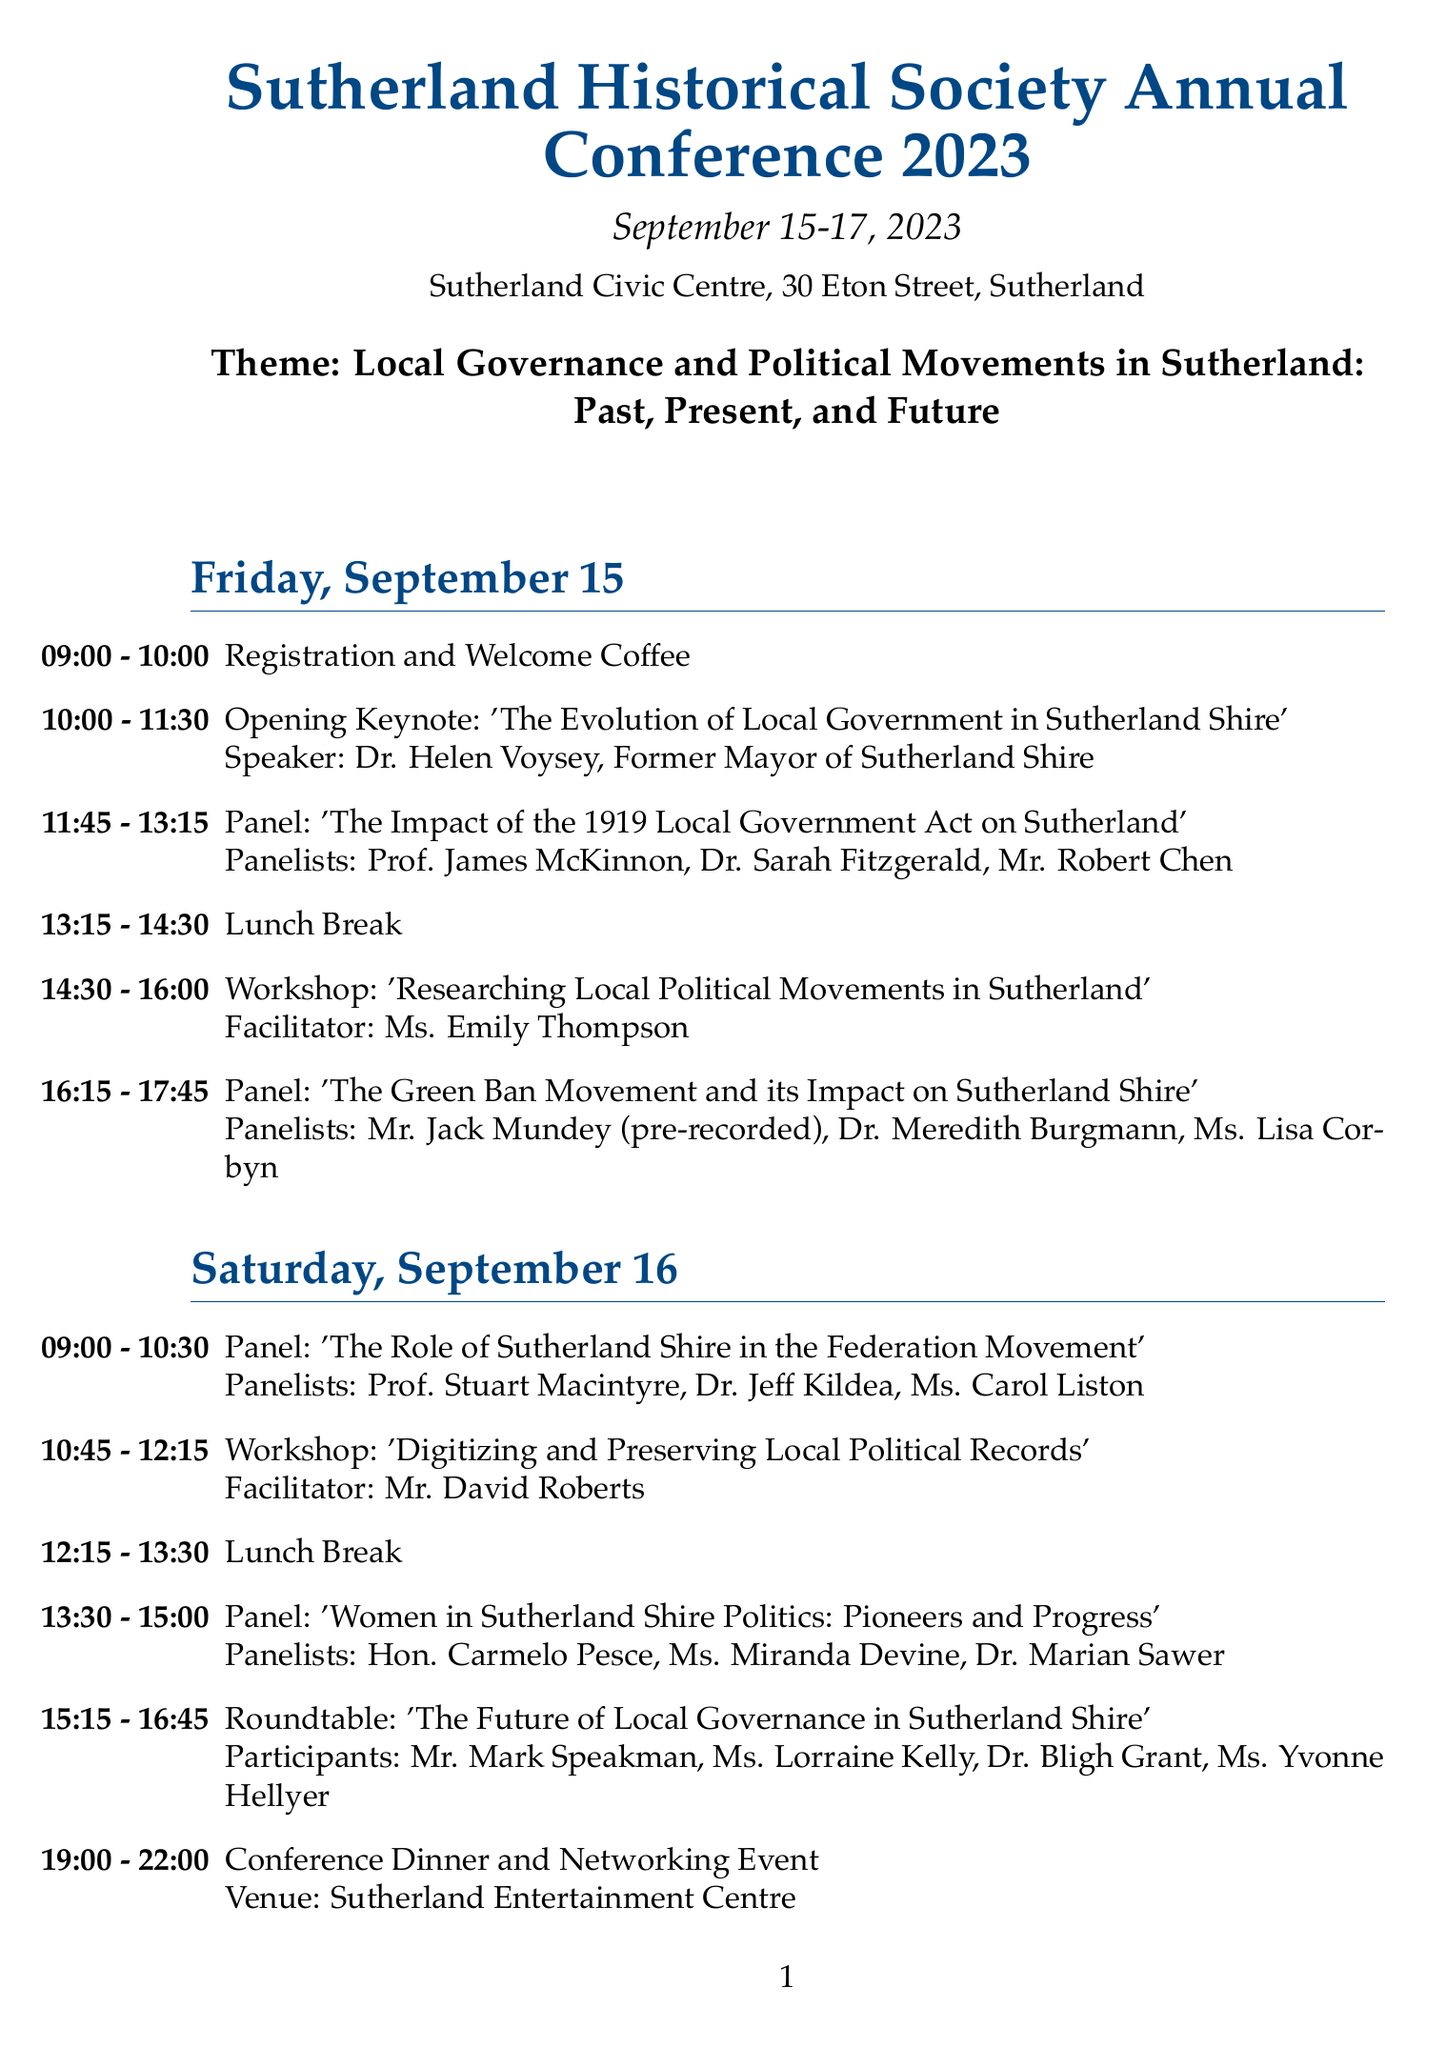What is the date of the conference? The conference is scheduled from September 15 to September 17, 2023.
Answer: September 15-17, 2023 Who is the speaker for the opening keynote? The opening keynote is presented by Dr. Helen Voysey, a former Mayor of Sutherland Shire.
Answer: Dr. Helen Voysey What time does the panel on the Green Ban Movement start? The panel discussing the Green Ban Movement is scheduled to start at 16:15.
Answer: 16:15 How many workshops are scheduled for Saturday? There are two workshops scheduled on Saturday: one at 10:45 and another on Sunday at 10:45.
Answer: 2 Who are the panelists for the discussion on Women in Sutherland Shire Politics? The panelists for this discussion include Hon. Carmelo Pesce, Ms. Miranda Devine, and Dr. Marian Sawer.
Answer: Hon. Carmelo Pesce, Ms. Miranda Devine, Dr. Marian Sawer What is the theme of the conference? The theme of the conference focuses on local governance and political movements in Sutherland.
Answer: Local Governance and Political Movements in Sutherland: Past, Present, and Future Which event is held at the Sutherland Entertainment Centre? The Conference Dinner and Networking Event takes place at the Sutherland Entertainment Centre.
Answer: Conference Dinner and Networking Event What time is the closing keynote scheduled for? The closing keynote is set to begin at 15:15.
Answer: 15:15 